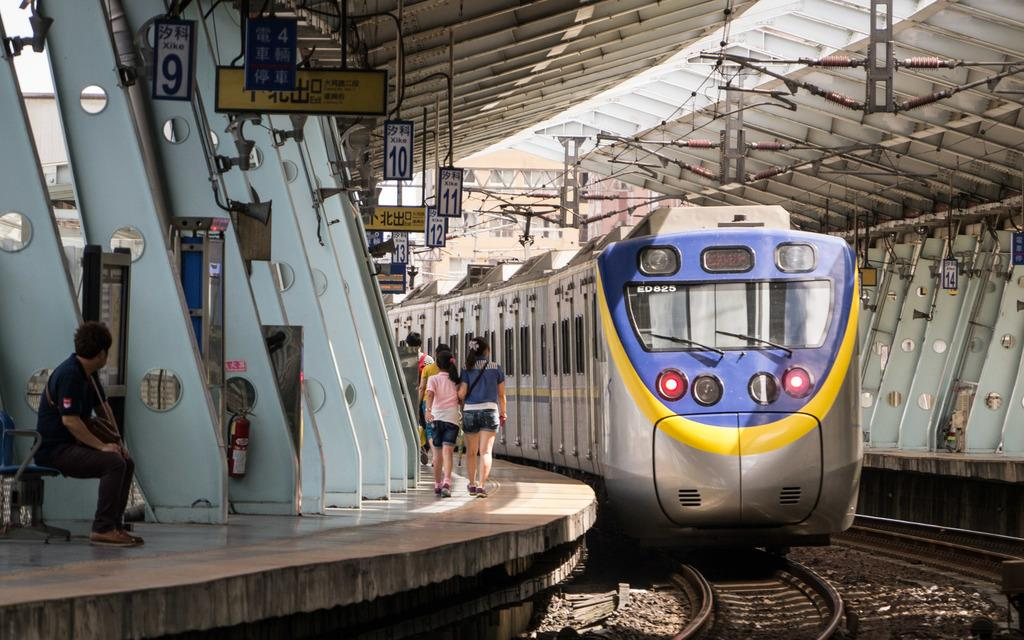What is the main subject of the image? The main subject of the image is a train on the track. Are there any people present in the image? Yes, there are people walking near the train, and there is a person sitting on a bench. Can you describe the person sitting on the bench? The person sitting on the bench is not described in the facts provided. What type of patch can be seen on the toy in the image? There is no toy or patch present in the image; it features a train on the track and people walking or sitting nearby. 